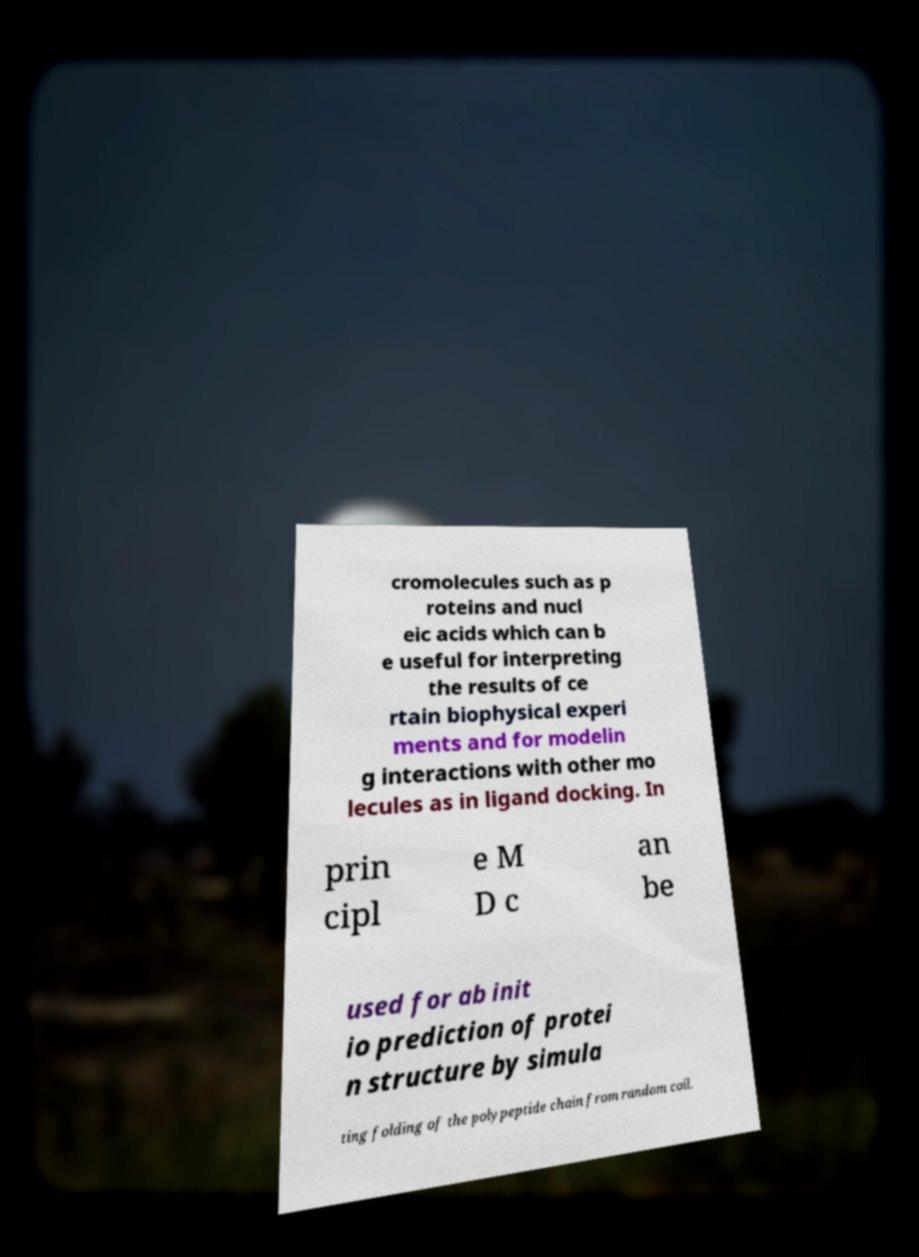What messages or text are displayed in this image? I need them in a readable, typed format. cromolecules such as p roteins and nucl eic acids which can b e useful for interpreting the results of ce rtain biophysical experi ments and for modelin g interactions with other mo lecules as in ligand docking. In prin cipl e M D c an be used for ab init io prediction of protei n structure by simula ting folding of the polypeptide chain from random coil. 